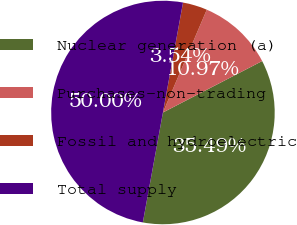Convert chart. <chart><loc_0><loc_0><loc_500><loc_500><pie_chart><fcel>Nuclear generation (a)<fcel>Purchases-non-trading<fcel>Fossil and hydroelectric<fcel>Total supply<nl><fcel>35.49%<fcel>10.97%<fcel>3.54%<fcel>50.0%<nl></chart> 